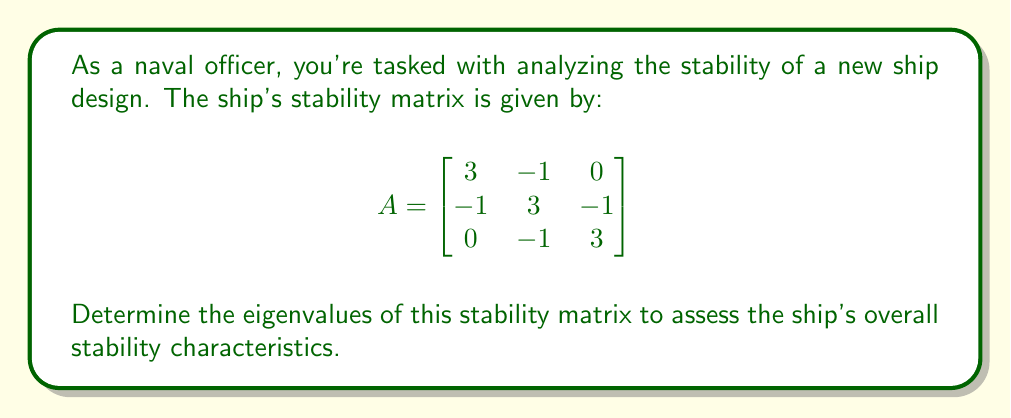Teach me how to tackle this problem. To find the eigenvalues of matrix A, we need to solve the characteristic equation:

$$det(A - \lambda I) = 0$$

Where $\lambda$ represents the eigenvalues and I is the 3x3 identity matrix.

Step 1: Set up the characteristic equation
$$det\begin{pmatrix}
3-\lambda & -1 & 0 \\
-1 & 3-\lambda & -1 \\
0 & -1 & 3-\lambda
\end{pmatrix} = 0$$

Step 2: Expand the determinant
$$(3-\lambda)[(3-\lambda)(3-\lambda) - 1] - (-1)[(-1)(3-\lambda) - 0] = 0$$

Step 3: Simplify
$$(3-\lambda)[(3-\lambda)^2 - 1] + (3-\lambda) = 0$$
$$(3-\lambda)[(3-\lambda)^2 - 1 + 1] = 0$$
$$(3-\lambda)(3-\lambda)^2 = 0$$

Step 4: Factor the equation
$$(3-\lambda)(3-\lambda)(3-\lambda) = 0$$
$$(3-\lambda)^3 = 0$$

Step 5: Solve for $\lambda$
$$3-\lambda = 0$$
$$\lambda = 3$$

Therefore, the eigenvalue $\lambda = 3$ has an algebraic multiplicity of 3.
Answer: $\lambda = 3$ (with algebraic multiplicity 3) 